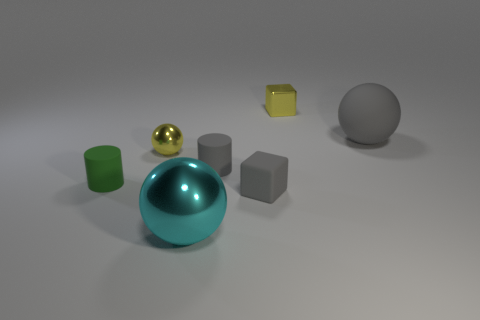Are the small green object and the cyan ball made of the same material?
Provide a short and direct response. No. There is a matte block that is the same color as the big rubber ball; what size is it?
Offer a very short reply. Small. Is there a small shiny block that has the same color as the large metallic sphere?
Provide a succinct answer. No. What is the size of the block that is the same material as the green cylinder?
Provide a short and direct response. Small. The yellow thing that is in front of the tiny yellow metal thing on the right side of the big object that is to the left of the tiny metallic cube is what shape?
Your answer should be compact. Sphere. The gray matte thing that is the same shape as the green thing is what size?
Your answer should be very brief. Small. There is a sphere that is both right of the small yellow metal sphere and in front of the large gray rubber object; what is its size?
Ensure brevity in your answer.  Large. There is a metallic thing that is the same color as the tiny metallic cube; what is its shape?
Your response must be concise. Sphere. What is the color of the metallic cube?
Offer a terse response. Yellow. What size is the gray rubber cylinder that is on the right side of the cyan object?
Offer a very short reply. Small. 